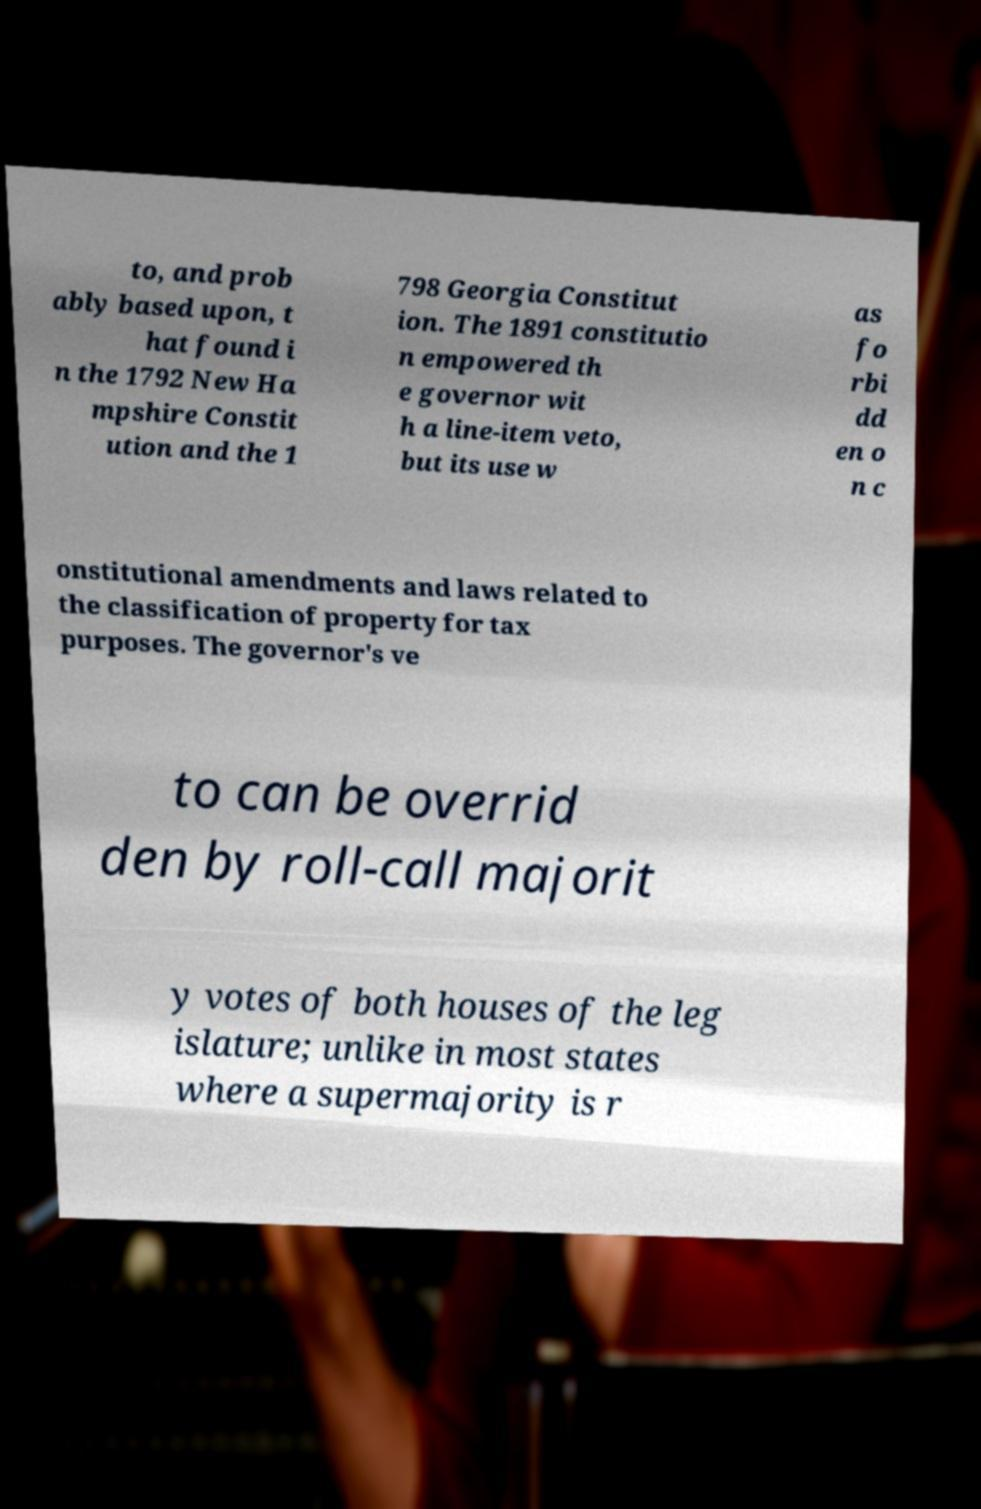There's text embedded in this image that I need extracted. Can you transcribe it verbatim? to, and prob ably based upon, t hat found i n the 1792 New Ha mpshire Constit ution and the 1 798 Georgia Constitut ion. The 1891 constitutio n empowered th e governor wit h a line-item veto, but its use w as fo rbi dd en o n c onstitutional amendments and laws related to the classification of property for tax purposes. The governor's ve to can be overrid den by roll-call majorit y votes of both houses of the leg islature; unlike in most states where a supermajority is r 